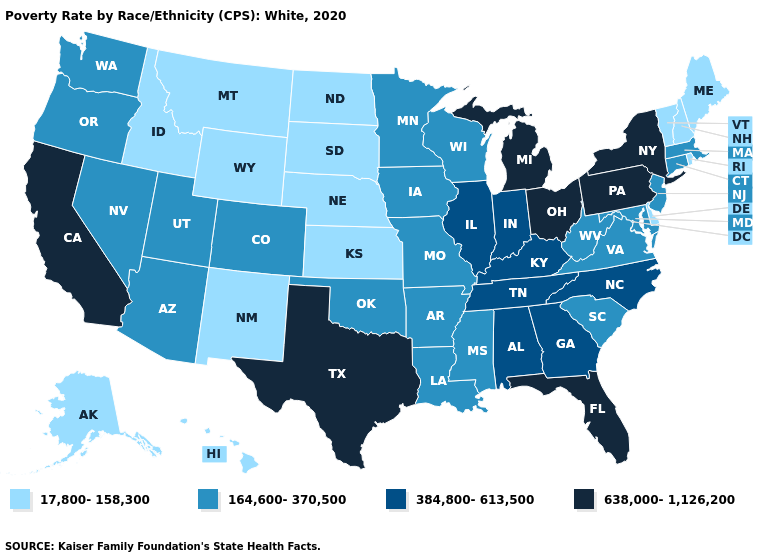Name the states that have a value in the range 164,600-370,500?
Give a very brief answer. Arizona, Arkansas, Colorado, Connecticut, Iowa, Louisiana, Maryland, Massachusetts, Minnesota, Mississippi, Missouri, Nevada, New Jersey, Oklahoma, Oregon, South Carolina, Utah, Virginia, Washington, West Virginia, Wisconsin. What is the lowest value in the USA?
Keep it brief. 17,800-158,300. Name the states that have a value in the range 17,800-158,300?
Give a very brief answer. Alaska, Delaware, Hawaii, Idaho, Kansas, Maine, Montana, Nebraska, New Hampshire, New Mexico, North Dakota, Rhode Island, South Dakota, Vermont, Wyoming. Which states have the lowest value in the USA?
Be succinct. Alaska, Delaware, Hawaii, Idaho, Kansas, Maine, Montana, Nebraska, New Hampshire, New Mexico, North Dakota, Rhode Island, South Dakota, Vermont, Wyoming. What is the value of Montana?
Short answer required. 17,800-158,300. How many symbols are there in the legend?
Short answer required. 4. What is the lowest value in the USA?
Be succinct. 17,800-158,300. Name the states that have a value in the range 638,000-1,126,200?
Short answer required. California, Florida, Michigan, New York, Ohio, Pennsylvania, Texas. What is the lowest value in states that border Kentucky?
Answer briefly. 164,600-370,500. What is the lowest value in the MidWest?
Write a very short answer. 17,800-158,300. What is the lowest value in the MidWest?
Keep it brief. 17,800-158,300. Name the states that have a value in the range 638,000-1,126,200?
Write a very short answer. California, Florida, Michigan, New York, Ohio, Pennsylvania, Texas. Name the states that have a value in the range 384,800-613,500?
Quick response, please. Alabama, Georgia, Illinois, Indiana, Kentucky, North Carolina, Tennessee. Name the states that have a value in the range 164,600-370,500?
Short answer required. Arizona, Arkansas, Colorado, Connecticut, Iowa, Louisiana, Maryland, Massachusetts, Minnesota, Mississippi, Missouri, Nevada, New Jersey, Oklahoma, Oregon, South Carolina, Utah, Virginia, Washington, West Virginia, Wisconsin. What is the lowest value in the USA?
Write a very short answer. 17,800-158,300. 